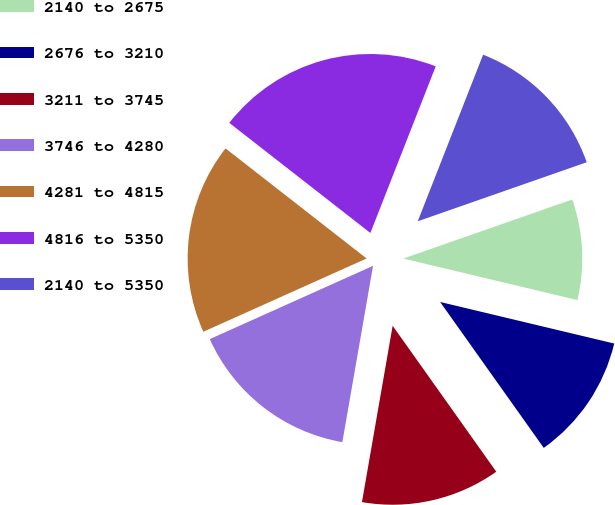Convert chart. <chart><loc_0><loc_0><loc_500><loc_500><pie_chart><fcel>2140 to 2675<fcel>2676 to 3210<fcel>3211 to 3745<fcel>3746 to 4280<fcel>4281 to 4815<fcel>4816 to 5350<fcel>2140 to 5350<nl><fcel>9.08%<fcel>11.44%<fcel>12.57%<fcel>15.54%<fcel>17.26%<fcel>20.4%<fcel>13.7%<nl></chart> 